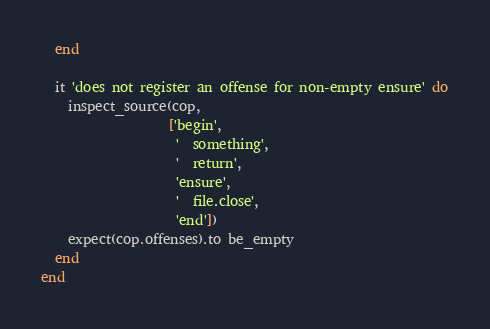<code> <loc_0><loc_0><loc_500><loc_500><_Ruby_>  end

  it 'does not register an offense for non-empty ensure' do
    inspect_source(cop,
                   ['begin',
                    '  something',
                    '  return',
                    'ensure',
                    '  file.close',
                    'end'])
    expect(cop.offenses).to be_empty
  end
end
</code> 